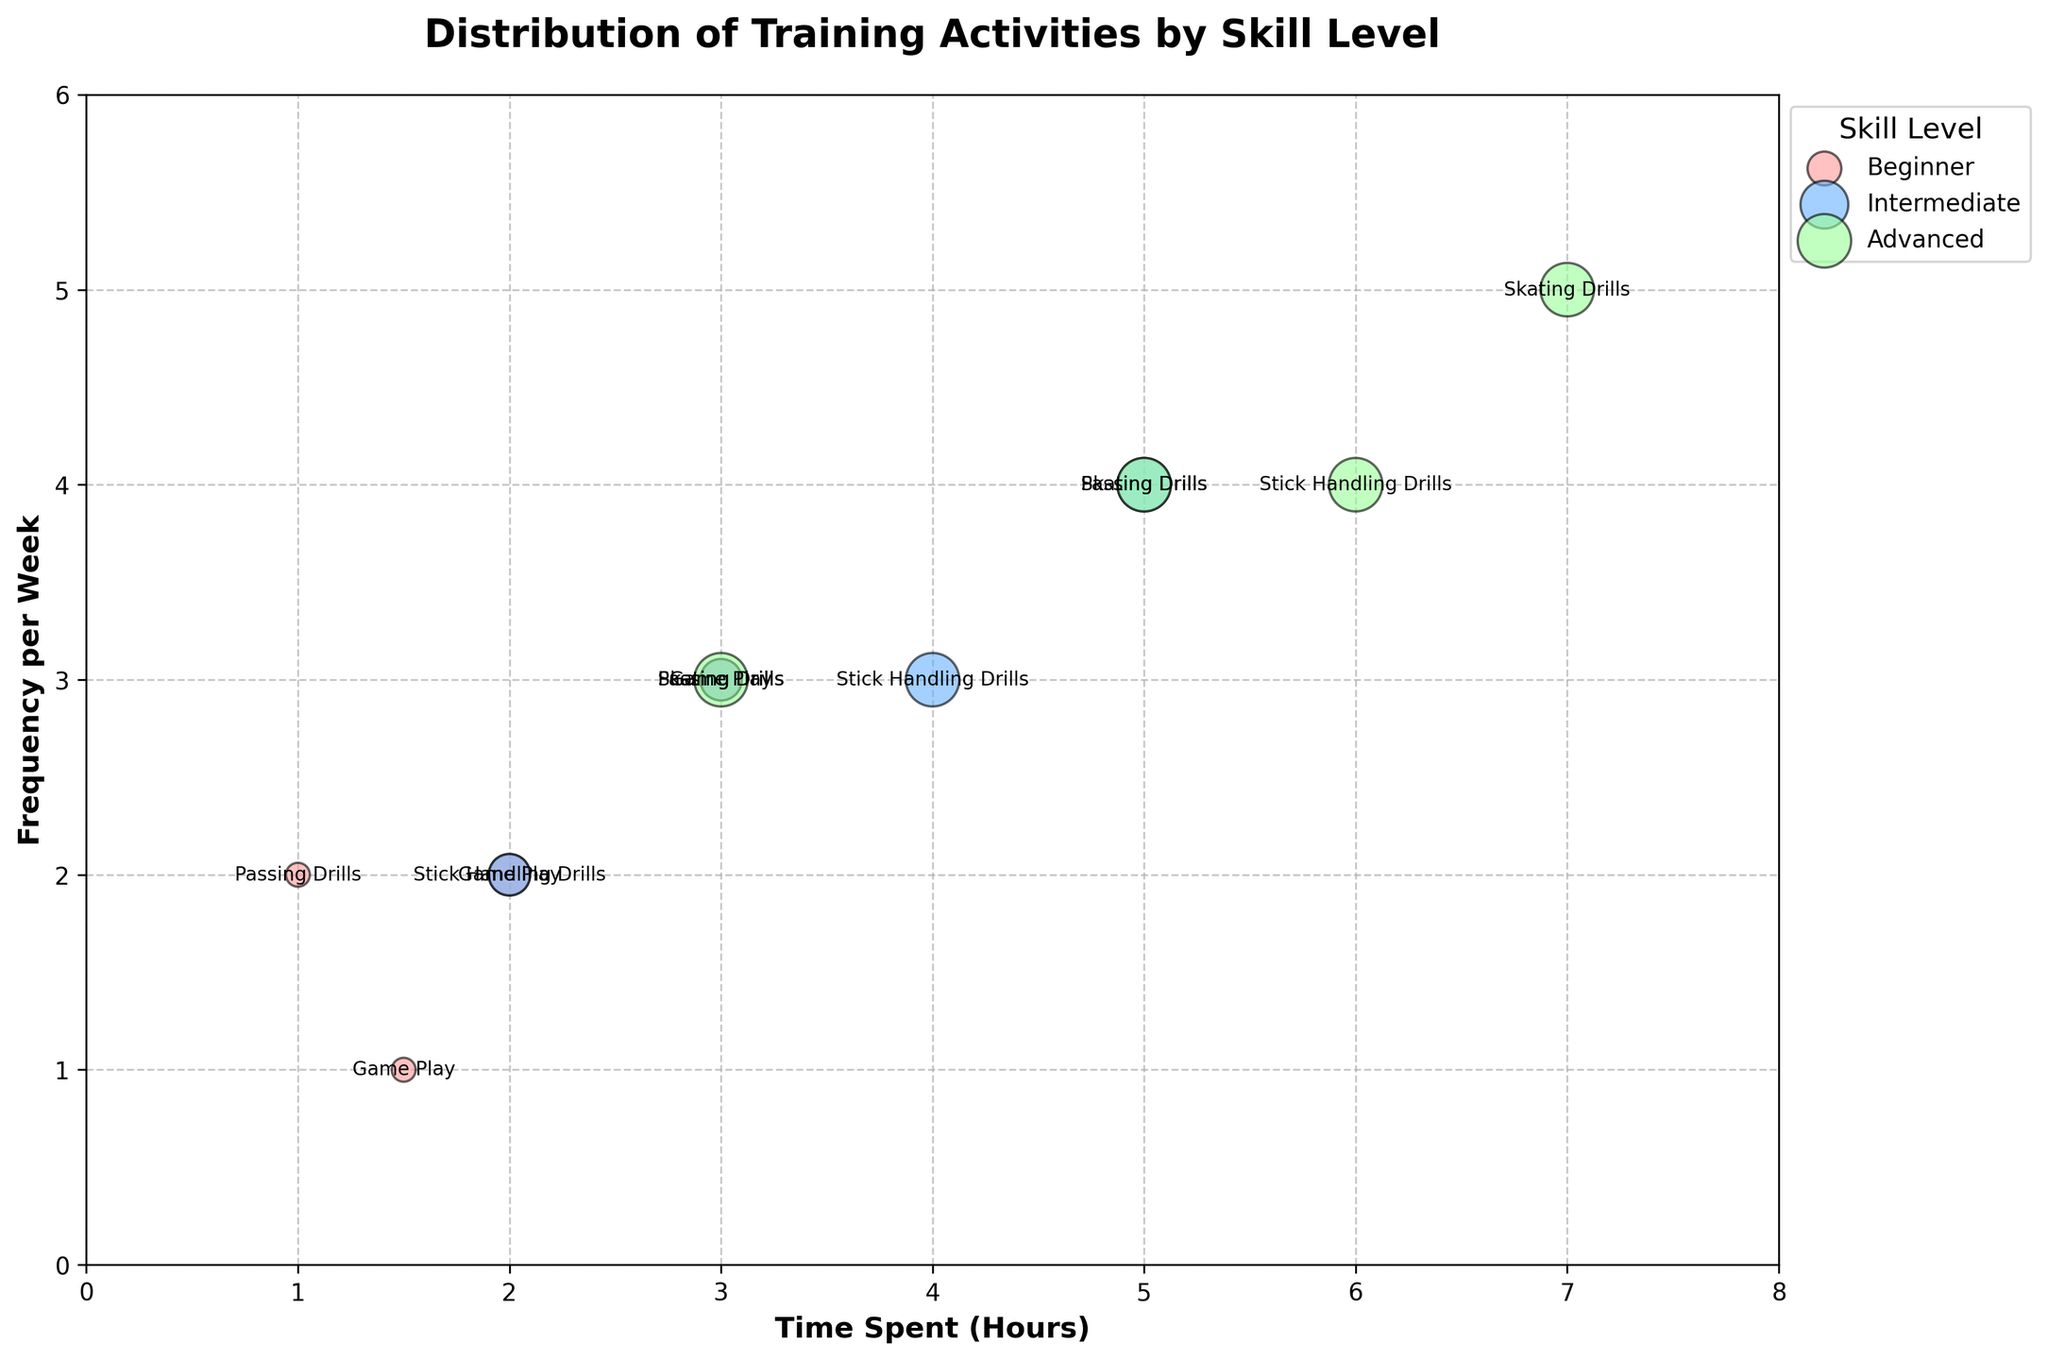What's the title of the figure? The title is written at the top of the figure and reads "Distribution of Training Activities by Skill Level".
Answer: Distribution of Training Activities by Skill Level What does the x-axis represent? The x-axis is labeled "Time Spent (Hours)", indicating it represents the amount of time spent in hours on training activities.
Answer: Time Spent (Hours) How many different skill levels are depicted in the figure? There are three distinct colored groups in the legend and scatter plot, corresponding to three different skill levels: Beginner, Intermediate, Advanced.
Answer: Three Which training activity has the highest intensity for Advanced skill level? By looking at the bubbles’ size, "Skating Drills," "Stick Handling Drills," "Passing Drills," and "Game Play" all have 'High' intensity (largest bubbles) in the Advanced skill level.
Answer: Skating Drills, Stick Handling Drills, Passing Drills, Game Play What is the skill level that spends the least time on "Stick Handling Drills"? By looking at the time spent for "Stick Handling Drills" across different skill levels, the Beginner skill level spends the least time, which is 2 hours.
Answer: Beginner Which training activity is performed most frequently by Intermediate players? Looking at the y-axis values for Intermediate players, "Skating Drills" is performed 4 times per week, the most frequent among other activities.
Answer: Skating Drills What's the total number of hours spent on "Game Play" at all skill levels? Summing the hours spent on "Game Play" for each skill level: Beginner (1.5 hours) + Intermediate (2 hours) + Advanced (3 hours) equals 6.5 hours.
Answer: 6.5 hours Which skill level has the highest average frequency per week of all training activities? Calculate the average frequency per week for each skill level and compare: Beginner's average is (3+2+2+1)/4 = 2; Intermediate's average is (4+3+3+2)/4 = 3; Advanced's average is (5+4+4+3)/4 = 4. Hence, Advanced has the highest average frequency per week.
Answer: Advanced How does the intensity of "Game Play" for Beginners compare to that for Advanced players? The size of the bubbles is smaller for Beginners and larger for Advanced players, indicating that the intensity of "Game Play" is 'Low' for Beginners and 'High' for Advanced players.
Answer: Lower for Beginners, Higher for Advanced What is the average time spent on "Skating Drills" across all skill levels? Calculate the average by summing the hours spent on "Skating Drills" then dividing by the number of skill levels: (3 + 5 + 7)/3 = 5 hours.
Answer: 5 hours 